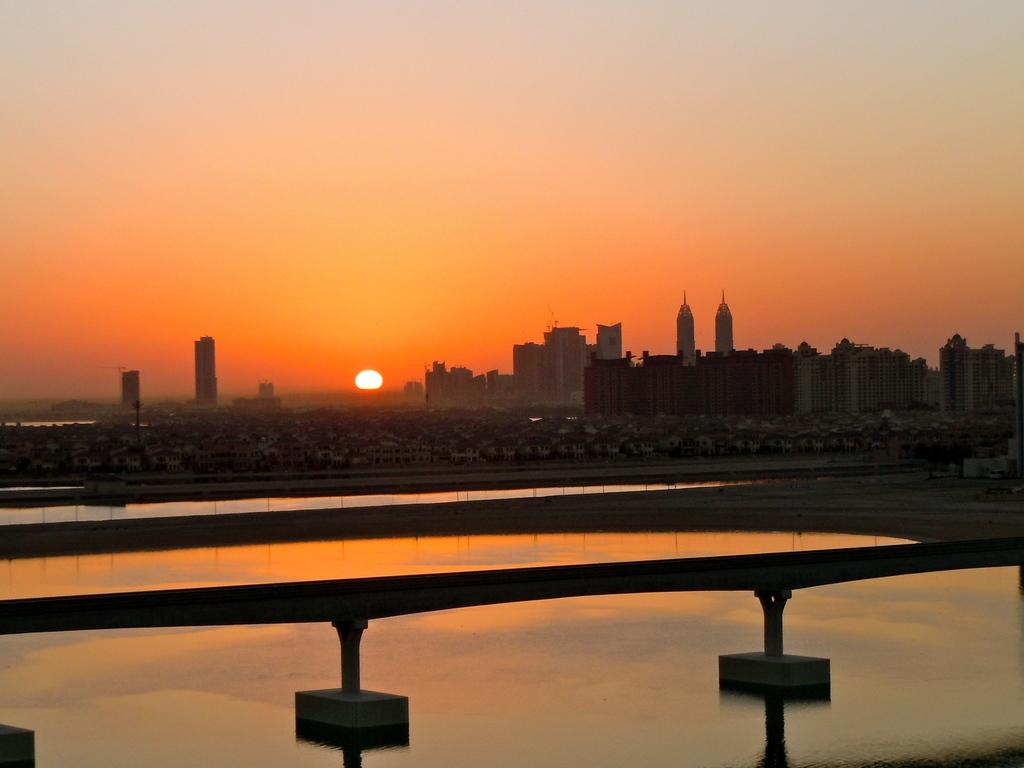What type of structures can be seen in the image? There are buildings in the image. What natural element is visible in the image? There is water visible in the image. What might be used to separate or protect an area in the image? There is a barrier in the image. What is visible in the background of the image? The sky is visible in the image. Can the sun be seen in the image? Yes, the sun is observable in the sky. What type of lace can be seen decorating the library in the image? There is no library or lace present in the image. How does the transport system operate in the image? There is no transport system visible in the image. 